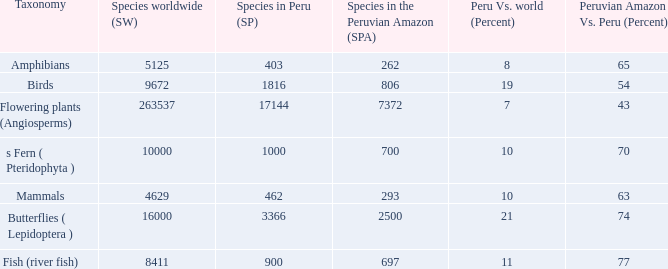What's the species in the world with peruvian amazon vs. peru (percent)  of 63 4629.0. 